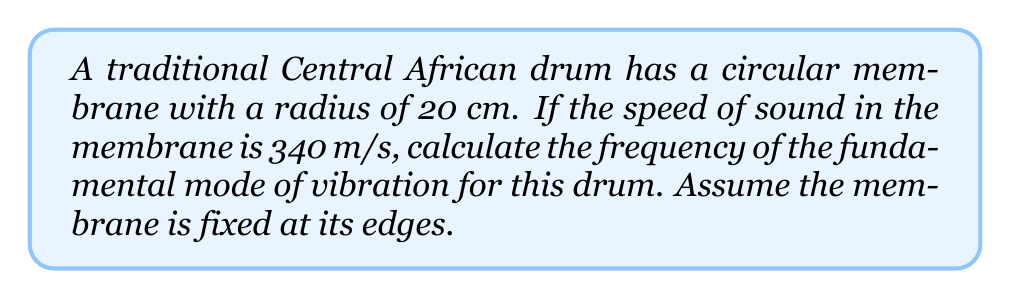Help me with this question. To solve this problem, we'll use the wave equation for a circular membrane. The steps are as follows:

1) The frequency of the fundamental mode for a circular membrane is given by:

   $$f = \frac{c \alpha_{01}}{2\pi a}$$

   Where:
   $f$ is the frequency
   $c$ is the speed of sound in the membrane
   $a$ is the radius of the membrane
   $\alpha_{01}$ is the first zero of the Bessel function of the first kind of order 0

2) We know:
   $c = 340$ m/s
   $a = 20$ cm = 0.2 m
   $\alpha_{01} \approx 2.4048$ (this is a constant)

3) Substituting these values into the equation:

   $$f = \frac{340 \cdot 2.4048}{2\pi \cdot 0.2}$$

4) Simplifying:
   $$f = \frac{817.632}{1.2566}$$

5) Calculating the final result:
   $$f \approx 650.67 \text{ Hz}$$
Answer: 650.67 Hz 